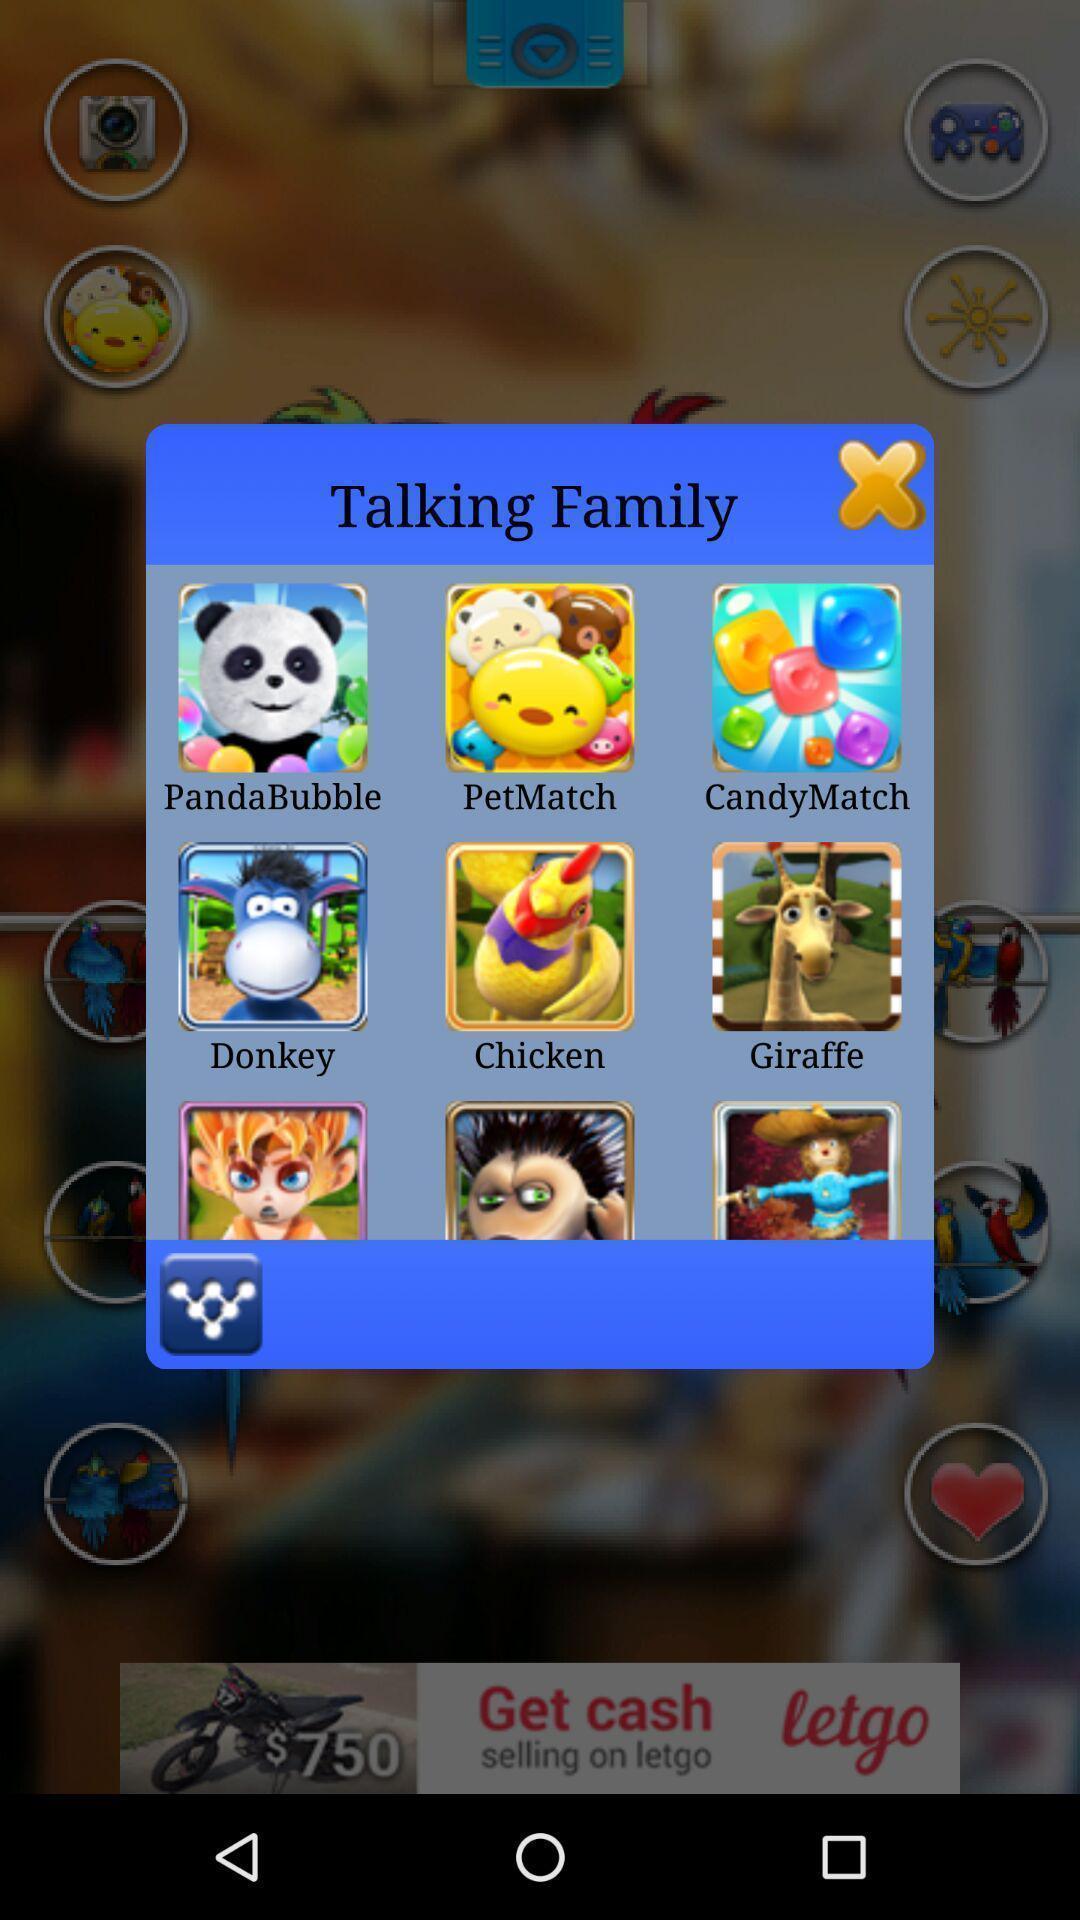Describe the visual elements of this screenshot. Pop-up for the gaming app icons. 